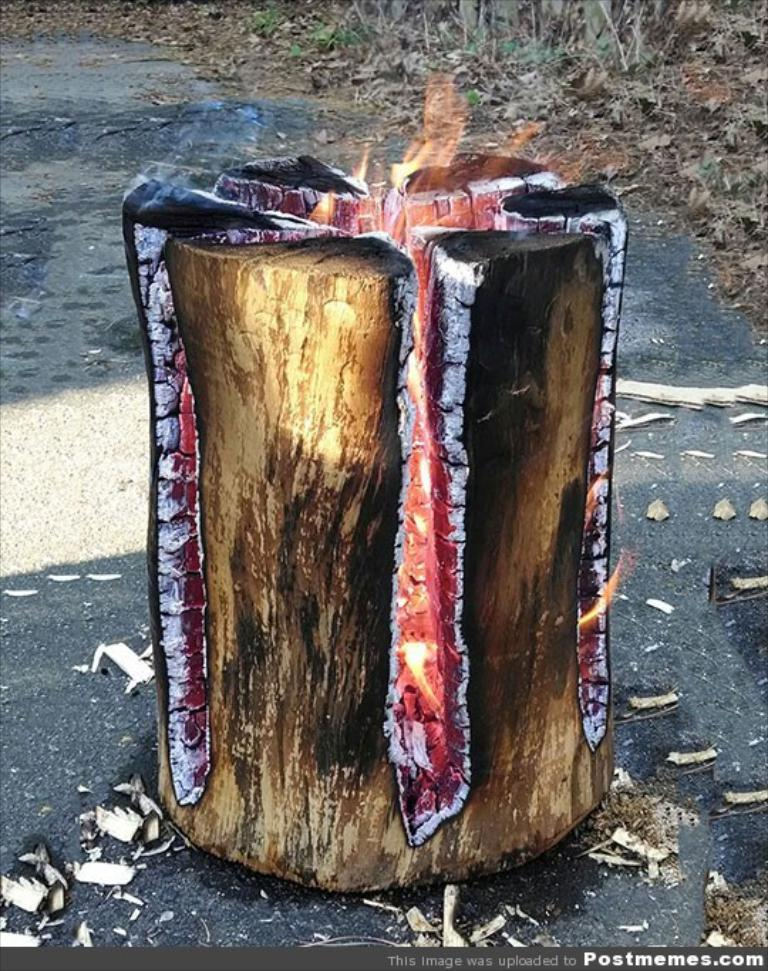What is the main subject in the center of the image? There is a fire log in the center of the image. What can be seen in the background of the image? There are leaves and grass in the background of the image. Where can you purchase a ticket for the harbor in the image? There is no harbor or ticket mentioned in the image; it only features a fire log and background vegetation. 